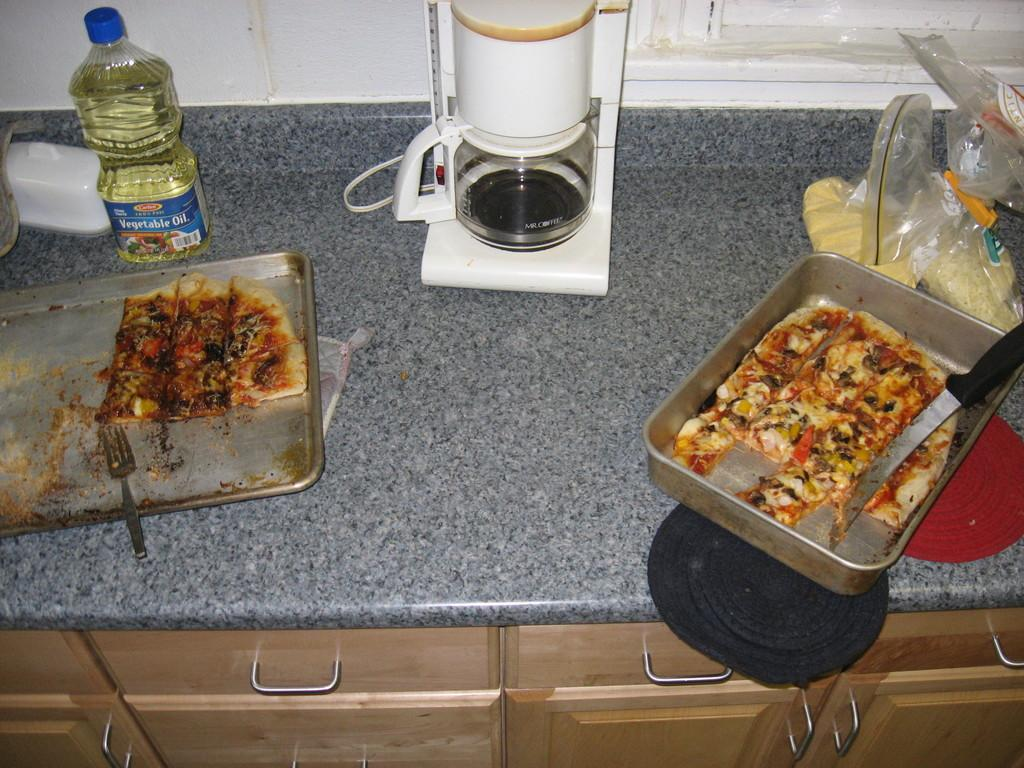<image>
Render a clear and concise summary of the photo. A bottle of Vegetable Oild beside a half eated pizza in a pan on a countertop 